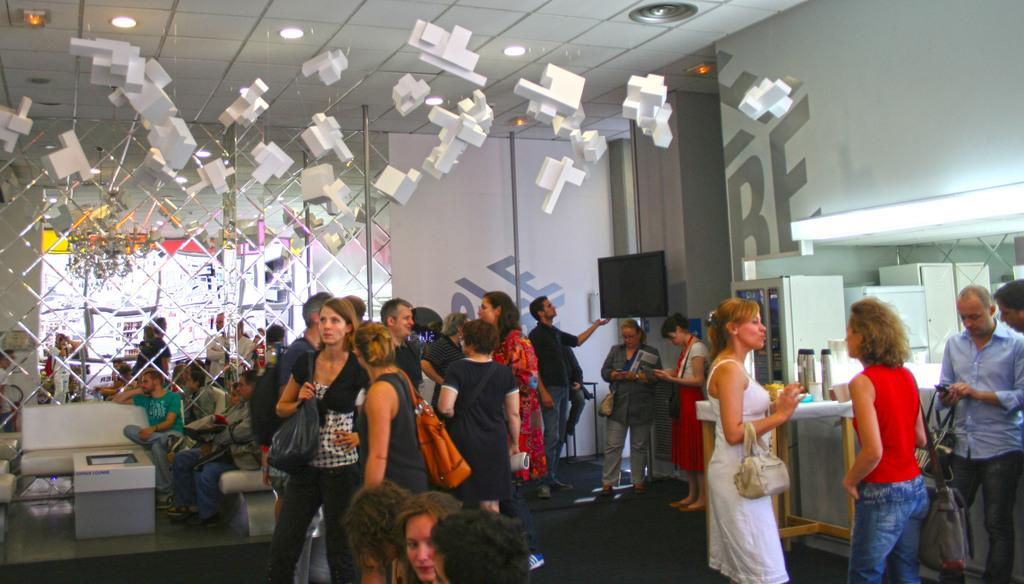How many people are present in the room? There are many people in the room. What can be found at the back of the room? There is a white couch and a screen at the back of the room. What type of objects are hanging in the room? White objects are hanging in the room. What is located at the top of the room? There are lights at the top of the room. What type of juice is being served to the people in the room? There is no mention of juice or any beverage being served in the image. 